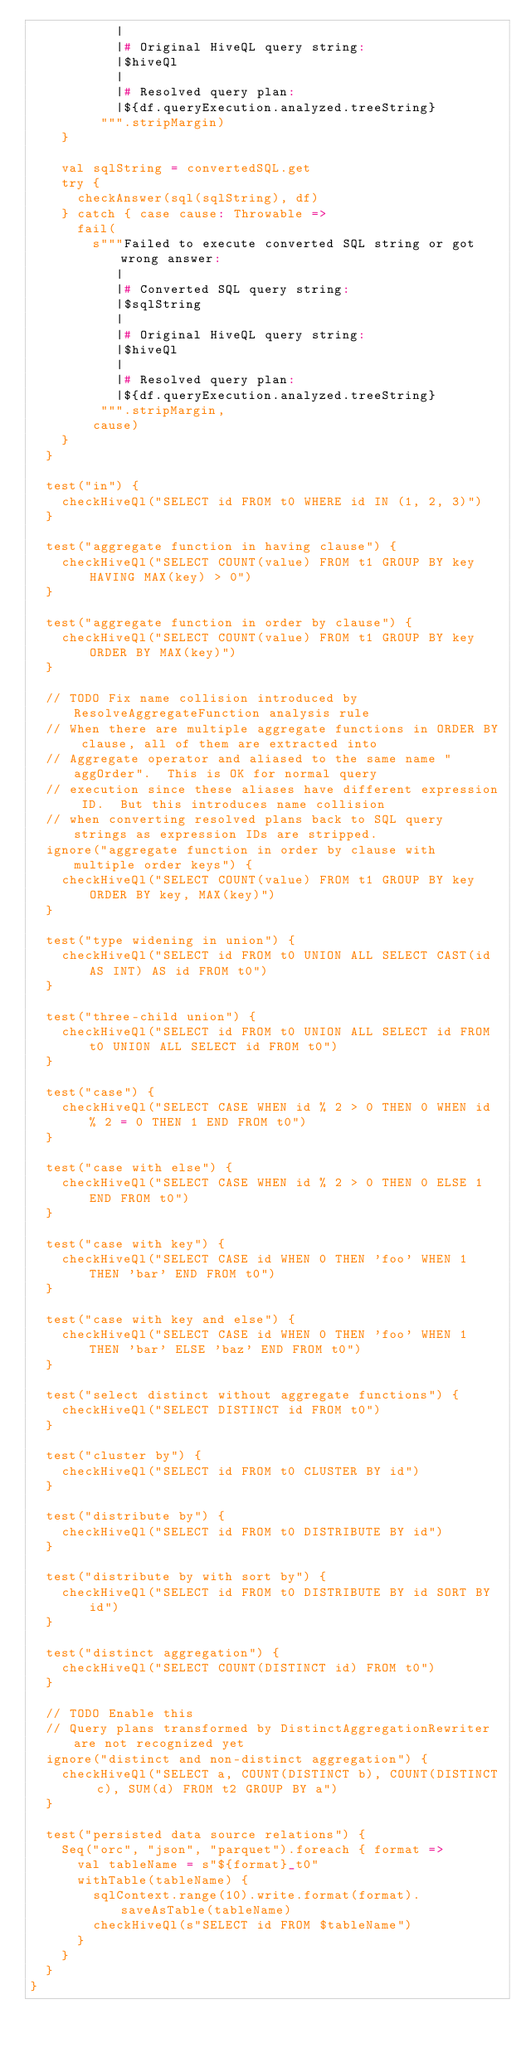Convert code to text. <code><loc_0><loc_0><loc_500><loc_500><_Scala_>           |
           |# Original HiveQL query string:
           |$hiveQl
           |
           |# Resolved query plan:
           |${df.queryExecution.analyzed.treeString}
         """.stripMargin)
    }

    val sqlString = convertedSQL.get
    try {
      checkAnswer(sql(sqlString), df)
    } catch { case cause: Throwable =>
      fail(
        s"""Failed to execute converted SQL string or got wrong answer:
           |
           |# Converted SQL query string:
           |$sqlString
           |
           |# Original HiveQL query string:
           |$hiveQl
           |
           |# Resolved query plan:
           |${df.queryExecution.analyzed.treeString}
         """.stripMargin,
        cause)
    }
  }

  test("in") {
    checkHiveQl("SELECT id FROM t0 WHERE id IN (1, 2, 3)")
  }

  test("aggregate function in having clause") {
    checkHiveQl("SELECT COUNT(value) FROM t1 GROUP BY key HAVING MAX(key) > 0")
  }

  test("aggregate function in order by clause") {
    checkHiveQl("SELECT COUNT(value) FROM t1 GROUP BY key ORDER BY MAX(key)")
  }

  // TODO Fix name collision introduced by ResolveAggregateFunction analysis rule
  // When there are multiple aggregate functions in ORDER BY clause, all of them are extracted into
  // Aggregate operator and aliased to the same name "aggOrder".  This is OK for normal query
  // execution since these aliases have different expression ID.  But this introduces name collision
  // when converting resolved plans back to SQL query strings as expression IDs are stripped.
  ignore("aggregate function in order by clause with multiple order keys") {
    checkHiveQl("SELECT COUNT(value) FROM t1 GROUP BY key ORDER BY key, MAX(key)")
  }

  test("type widening in union") {
    checkHiveQl("SELECT id FROM t0 UNION ALL SELECT CAST(id AS INT) AS id FROM t0")
  }

  test("three-child union") {
    checkHiveQl("SELECT id FROM t0 UNION ALL SELECT id FROM t0 UNION ALL SELECT id FROM t0")
  }

  test("case") {
    checkHiveQl("SELECT CASE WHEN id % 2 > 0 THEN 0 WHEN id % 2 = 0 THEN 1 END FROM t0")
  }

  test("case with else") {
    checkHiveQl("SELECT CASE WHEN id % 2 > 0 THEN 0 ELSE 1 END FROM t0")
  }

  test("case with key") {
    checkHiveQl("SELECT CASE id WHEN 0 THEN 'foo' WHEN 1 THEN 'bar' END FROM t0")
  }

  test("case with key and else") {
    checkHiveQl("SELECT CASE id WHEN 0 THEN 'foo' WHEN 1 THEN 'bar' ELSE 'baz' END FROM t0")
  }

  test("select distinct without aggregate functions") {
    checkHiveQl("SELECT DISTINCT id FROM t0")
  }

  test("cluster by") {
    checkHiveQl("SELECT id FROM t0 CLUSTER BY id")
  }

  test("distribute by") {
    checkHiveQl("SELECT id FROM t0 DISTRIBUTE BY id")
  }

  test("distribute by with sort by") {
    checkHiveQl("SELECT id FROM t0 DISTRIBUTE BY id SORT BY id")
  }

  test("distinct aggregation") {
    checkHiveQl("SELECT COUNT(DISTINCT id) FROM t0")
  }

  // TODO Enable this
  // Query plans transformed by DistinctAggregationRewriter are not recognized yet
  ignore("distinct and non-distinct aggregation") {
    checkHiveQl("SELECT a, COUNT(DISTINCT b), COUNT(DISTINCT c), SUM(d) FROM t2 GROUP BY a")
  }

  test("persisted data source relations") {
    Seq("orc", "json", "parquet").foreach { format =>
      val tableName = s"${format}_t0"
      withTable(tableName) {
        sqlContext.range(10).write.format(format).saveAsTable(tableName)
        checkHiveQl(s"SELECT id FROM $tableName")
      }
    }
  }
}
</code> 